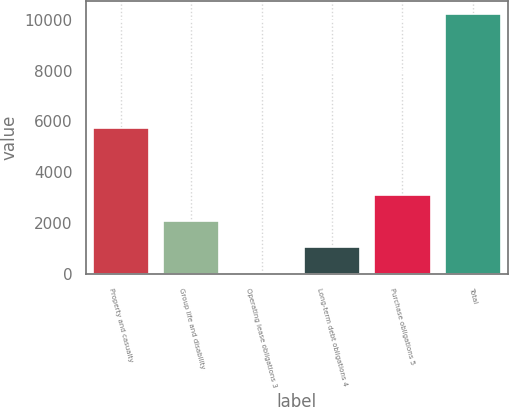Convert chart to OTSL. <chart><loc_0><loc_0><loc_500><loc_500><bar_chart><fcel>Property and casualty<fcel>Group life and disability<fcel>Operating lease obligations 3<fcel>Long-term debt obligations 4<fcel>Purchase obligations 5<fcel>Total<nl><fcel>5740<fcel>2079.4<fcel>44<fcel>1061.7<fcel>3097.1<fcel>10221<nl></chart> 